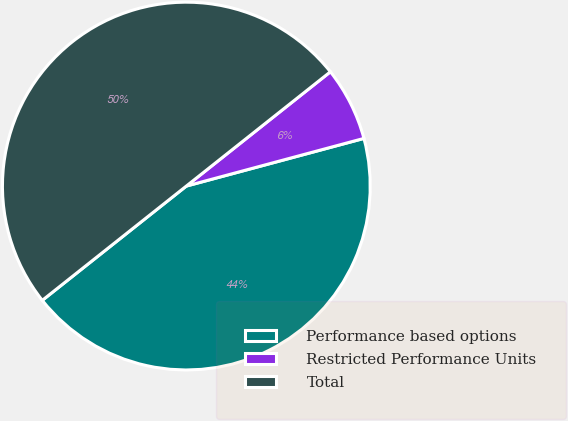<chart> <loc_0><loc_0><loc_500><loc_500><pie_chart><fcel>Performance based options<fcel>Restricted Performance Units<fcel>Total<nl><fcel>43.5%<fcel>6.5%<fcel>50.0%<nl></chart> 